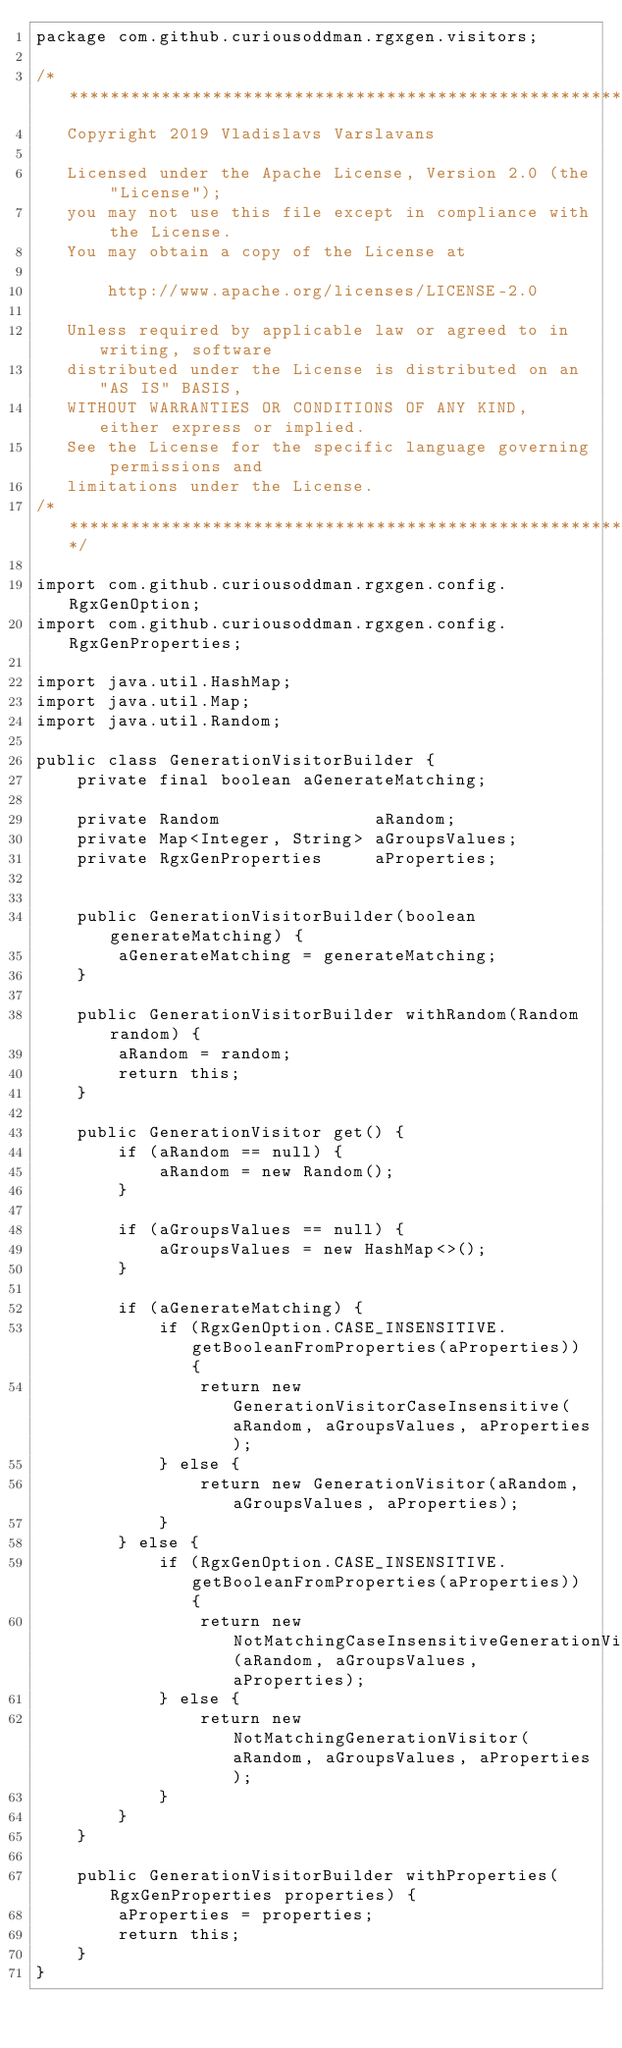<code> <loc_0><loc_0><loc_500><loc_500><_Java_>package com.github.curiousoddman.rgxgen.visitors;

/* **************************************************************************
   Copyright 2019 Vladislavs Varslavans

   Licensed under the Apache License, Version 2.0 (the "License");
   you may not use this file except in compliance with the License.
   You may obtain a copy of the License at

       http://www.apache.org/licenses/LICENSE-2.0

   Unless required by applicable law or agreed to in writing, software
   distributed under the License is distributed on an "AS IS" BASIS,
   WITHOUT WARRANTIES OR CONDITIONS OF ANY KIND, either express or implied.
   See the License for the specific language governing permissions and
   limitations under the License.
/* **************************************************************************/

import com.github.curiousoddman.rgxgen.config.RgxGenOption;
import com.github.curiousoddman.rgxgen.config.RgxGenProperties;

import java.util.HashMap;
import java.util.Map;
import java.util.Random;

public class GenerationVisitorBuilder {
    private final boolean aGenerateMatching;

    private Random               aRandom;
    private Map<Integer, String> aGroupsValues;
    private RgxGenProperties     aProperties;


    public GenerationVisitorBuilder(boolean generateMatching) {
        aGenerateMatching = generateMatching;
    }

    public GenerationVisitorBuilder withRandom(Random random) {
        aRandom = random;
        return this;
    }

    public GenerationVisitor get() {
        if (aRandom == null) {
            aRandom = new Random();
        }

        if (aGroupsValues == null) {
            aGroupsValues = new HashMap<>();
        }

        if (aGenerateMatching) {
            if (RgxGenOption.CASE_INSENSITIVE.getBooleanFromProperties(aProperties)) {
                return new GenerationVisitorCaseInsensitive(aRandom, aGroupsValues, aProperties);
            } else {
                return new GenerationVisitor(aRandom, aGroupsValues, aProperties);
            }
        } else {
            if (RgxGenOption.CASE_INSENSITIVE.getBooleanFromProperties(aProperties)) {
                return new NotMatchingCaseInsensitiveGenerationVisitor(aRandom, aGroupsValues, aProperties);
            } else {
                return new NotMatchingGenerationVisitor(aRandom, aGroupsValues, aProperties);
            }
        }
    }

    public GenerationVisitorBuilder withProperties(RgxGenProperties properties) {
        aProperties = properties;
        return this;
    }
}
</code> 